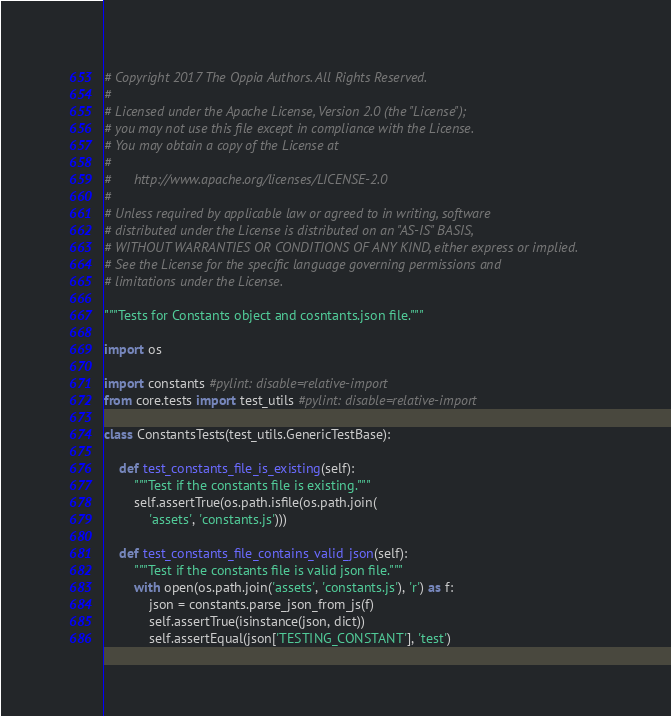Convert code to text. <code><loc_0><loc_0><loc_500><loc_500><_Python_># Copyright 2017 The Oppia Authors. All Rights Reserved.
#
# Licensed under the Apache License, Version 2.0 (the "License");
# you may not use this file except in compliance with the License.
# You may obtain a copy of the License at
#
#      http://www.apache.org/licenses/LICENSE-2.0
#
# Unless required by applicable law or agreed to in writing, software
# distributed under the License is distributed on an "AS-IS" BASIS,
# WITHOUT WARRANTIES OR CONDITIONS OF ANY KIND, either express or implied.
# See the License for the specific language governing permissions and
# limitations under the License.

"""Tests for Constants object and cosntants.json file."""

import os

import constants #pylint: disable=relative-import
from core.tests import test_utils #pylint: disable=relative-import

class ConstantsTests(test_utils.GenericTestBase):

    def test_constants_file_is_existing(self):
        """Test if the constants file is existing."""
        self.assertTrue(os.path.isfile(os.path.join(
            'assets', 'constants.js')))

    def test_constants_file_contains_valid_json(self):
        """Test if the constants file is valid json file."""
        with open(os.path.join('assets', 'constants.js'), 'r') as f:
            json = constants.parse_json_from_js(f)
            self.assertTrue(isinstance(json, dict))
            self.assertEqual(json['TESTING_CONSTANT'], 'test')
</code> 